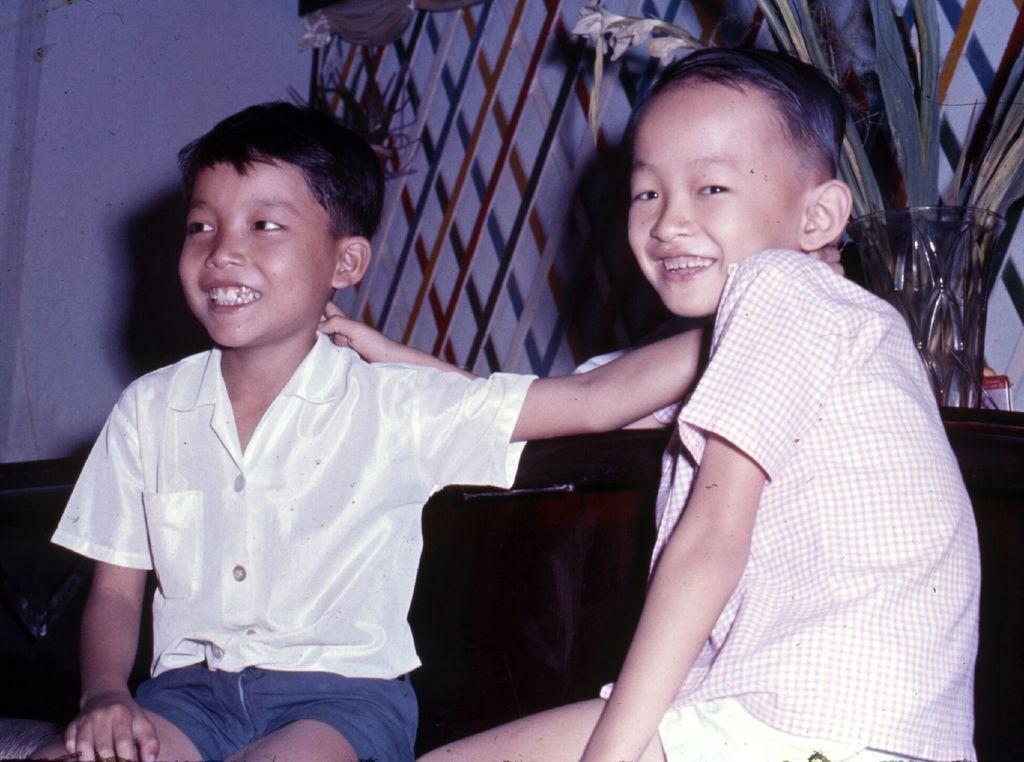How would you summarize this image in a sentence or two? This image consists of two kids. They are boys. There is a flower vase on the right side. 